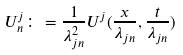Convert formula to latex. <formula><loc_0><loc_0><loc_500><loc_500>U ^ { j } _ { n } \colon = \frac { 1 } { \lambda ^ { 2 } _ { j n } } U ^ { j } ( \frac { x } { \lambda _ { j n } } , \frac { t } { \lambda _ { j n } } )</formula> 